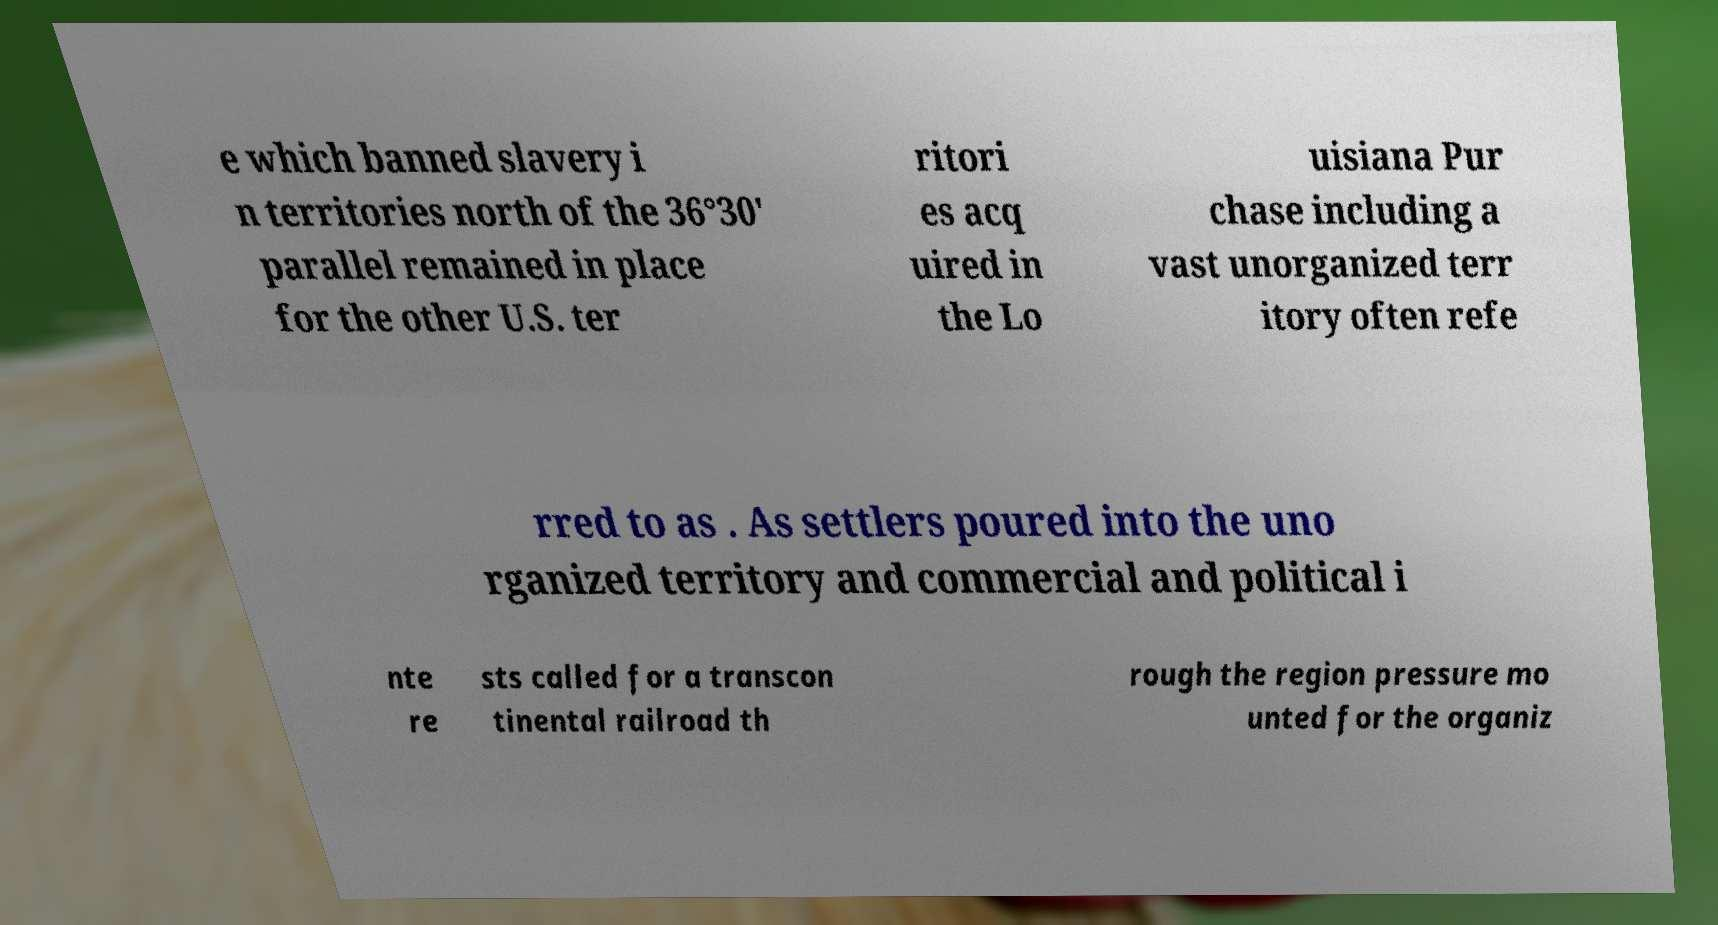Please identify and transcribe the text found in this image. e which banned slavery i n territories north of the 36°30′ parallel remained in place for the other U.S. ter ritori es acq uired in the Lo uisiana Pur chase including a vast unorganized terr itory often refe rred to as . As settlers poured into the uno rganized territory and commercial and political i nte re sts called for a transcon tinental railroad th rough the region pressure mo unted for the organiz 